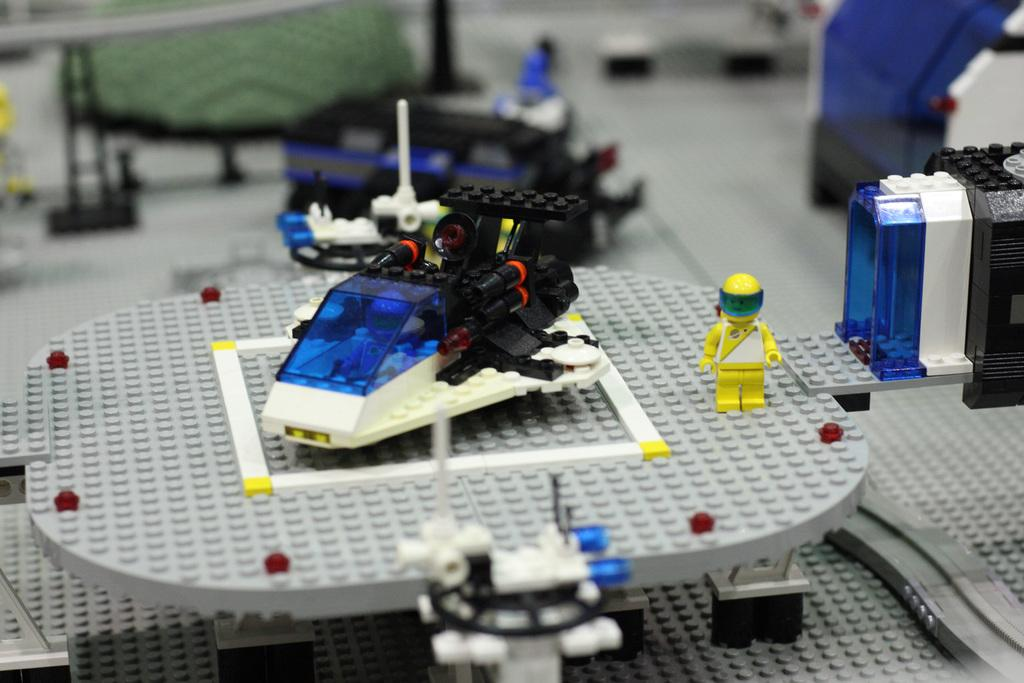What is the main subject of the image? The main subject of the image is a miniature art made of blocks. What can be seen in the center of the miniature art? There is a vehicle in the center of the miniature art. Is there a person present in the image? Yes, there is a person standing beside the vehicle. Can you describe the top part of the image? The top part of the image is blurry. What letters can be seen on the railway in the image? There is no railway present in the image, so no letters can be seen on it. 